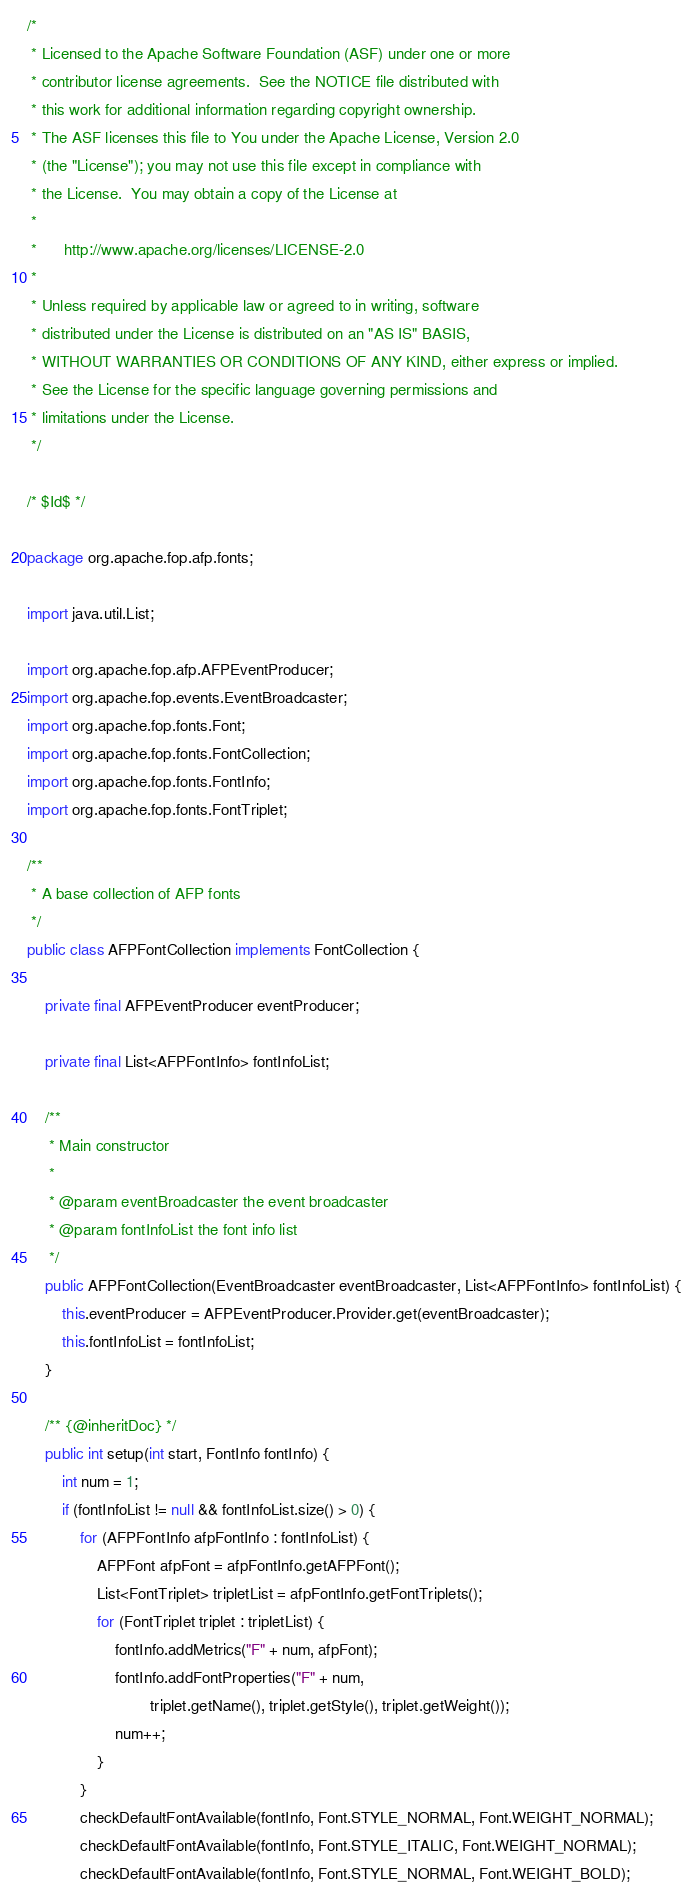Convert code to text. <code><loc_0><loc_0><loc_500><loc_500><_Java_>/*
 * Licensed to the Apache Software Foundation (ASF) under one or more
 * contributor license agreements.  See the NOTICE file distributed with
 * this work for additional information regarding copyright ownership.
 * The ASF licenses this file to You under the Apache License, Version 2.0
 * (the "License"); you may not use this file except in compliance with
 * the License.  You may obtain a copy of the License at
 *
 *      http://www.apache.org/licenses/LICENSE-2.0
 *
 * Unless required by applicable law or agreed to in writing, software
 * distributed under the License is distributed on an "AS IS" BASIS,
 * WITHOUT WARRANTIES OR CONDITIONS OF ANY KIND, either express or implied.
 * See the License for the specific language governing permissions and
 * limitations under the License.
 */

/* $Id$ */

package org.apache.fop.afp.fonts;

import java.util.List;

import org.apache.fop.afp.AFPEventProducer;
import org.apache.fop.events.EventBroadcaster;
import org.apache.fop.fonts.Font;
import org.apache.fop.fonts.FontCollection;
import org.apache.fop.fonts.FontInfo;
import org.apache.fop.fonts.FontTriplet;

/**
 * A base collection of AFP fonts
 */
public class AFPFontCollection implements FontCollection {

    private final AFPEventProducer eventProducer;

    private final List<AFPFontInfo> fontInfoList;

    /**
     * Main constructor
     *
     * @param eventBroadcaster the event broadcaster
     * @param fontInfoList the font info list
     */
    public AFPFontCollection(EventBroadcaster eventBroadcaster, List<AFPFontInfo> fontInfoList) {
        this.eventProducer = AFPEventProducer.Provider.get(eventBroadcaster);
        this.fontInfoList = fontInfoList;
    }

    /** {@inheritDoc} */
    public int setup(int start, FontInfo fontInfo) {
        int num = 1;
        if (fontInfoList != null && fontInfoList.size() > 0) {
            for (AFPFontInfo afpFontInfo : fontInfoList) {
                AFPFont afpFont = afpFontInfo.getAFPFont();
                List<FontTriplet> tripletList = afpFontInfo.getFontTriplets();
                for (FontTriplet triplet : tripletList) {
                    fontInfo.addMetrics("F" + num, afpFont);
                    fontInfo.addFontProperties("F" + num,
                            triplet.getName(), triplet.getStyle(), triplet.getWeight());
                    num++;
                }
            }
            checkDefaultFontAvailable(fontInfo, Font.STYLE_NORMAL, Font.WEIGHT_NORMAL);
            checkDefaultFontAvailable(fontInfo, Font.STYLE_ITALIC, Font.WEIGHT_NORMAL);
            checkDefaultFontAvailable(fontInfo, Font.STYLE_NORMAL, Font.WEIGHT_BOLD);</code> 